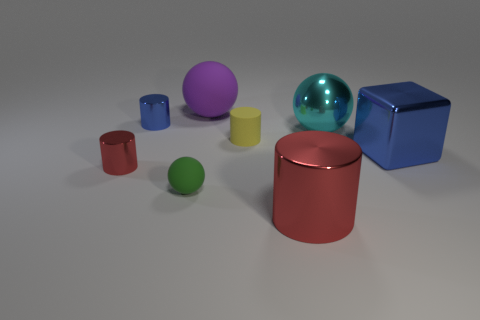Is there any other thing that is the same shape as the large blue shiny thing?
Your response must be concise. No. How many small balls are the same material as the large red cylinder?
Offer a terse response. 0. Does the red metallic object on the left side of the big cylinder have the same size as the metallic cylinder that is behind the small red object?
Make the answer very short. Yes. The tiny thing that is to the right of the ball in front of the red cylinder to the left of the tiny blue metal cylinder is what color?
Your response must be concise. Yellow. Are there any green rubber things of the same shape as the big cyan metallic object?
Give a very brief answer. Yes. Are there the same number of metallic things that are behind the tiny blue shiny thing and tiny matte objects behind the purple sphere?
Your answer should be compact. Yes. Is the shape of the blue metal object that is to the left of the big blue cube the same as  the small red thing?
Keep it short and to the point. Yes. Is the shape of the purple object the same as the green rubber object?
Your answer should be compact. Yes. What number of metallic objects are either small blue things or big cyan objects?
Make the answer very short. 2. There is a thing that is the same color as the big metal block; what is it made of?
Your answer should be compact. Metal. 